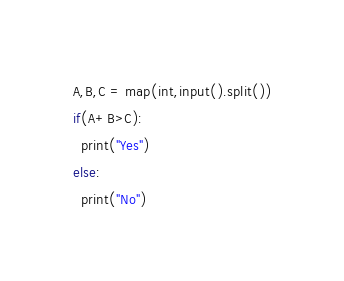Convert code to text. <code><loc_0><loc_0><loc_500><loc_500><_Python_>A,B,C = map(int,input().split())
if(A+B>C):
  print("Yes")
else:
  print("No")</code> 